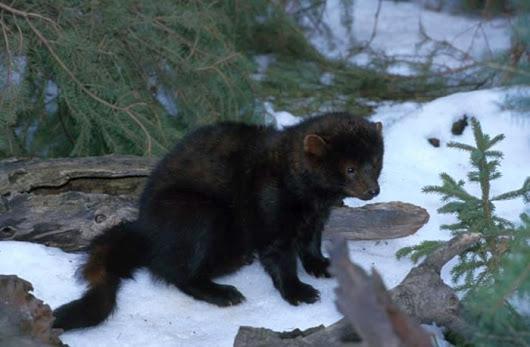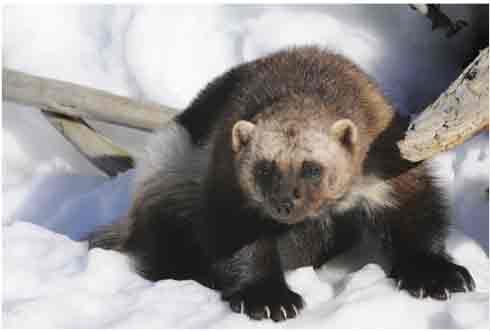The first image is the image on the left, the second image is the image on the right. Considering the images on both sides, is "The animal in one of the images is situated in the grass." valid? Answer yes or no. No. The first image is the image on the left, the second image is the image on the right. Analyze the images presented: Is the assertion "there is a ferret in tall grass" valid? Answer yes or no. No. 